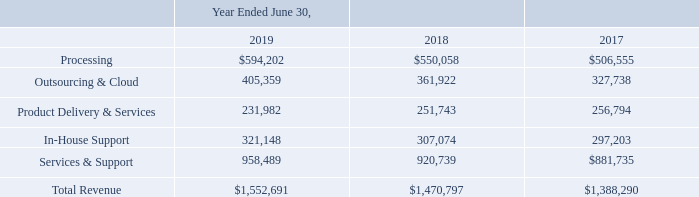Disaggregation of Revenue
The tables below present the Company’s revenue disaggregated by type of revenue. Refer to Note 13, Reportable Segment Information, for disaggregated revenue by type and reportable segment. The majority of the Company’s revenue is earned domestically, with revenue from customers outside the United States comprising less than 1% of total revenue.
What does the table present? The company’s revenue disaggregated by type of revenue. What are the types of revenue shown in the table? Processing, outsourcing & cloud, product delivery & services, in-house support, services & support. What is the total revenue as of year ended June 30, 2019? $1,552,691. What is the average processing revenue for 2018 and 2019? ($594,202+$550,058)/2
Answer: 572130. What is the average outsourcing & cloud revenue for 2018 and 2019? (405,359+361,922)/2
Answer: 383640.5. What is the difference between the average processing revenue and the average outsourcing & cloud revenue for 2018-2019? [($594,202+$550,058)/2] - [(405,359+361,922)/2]
Answer: 188489.5. 